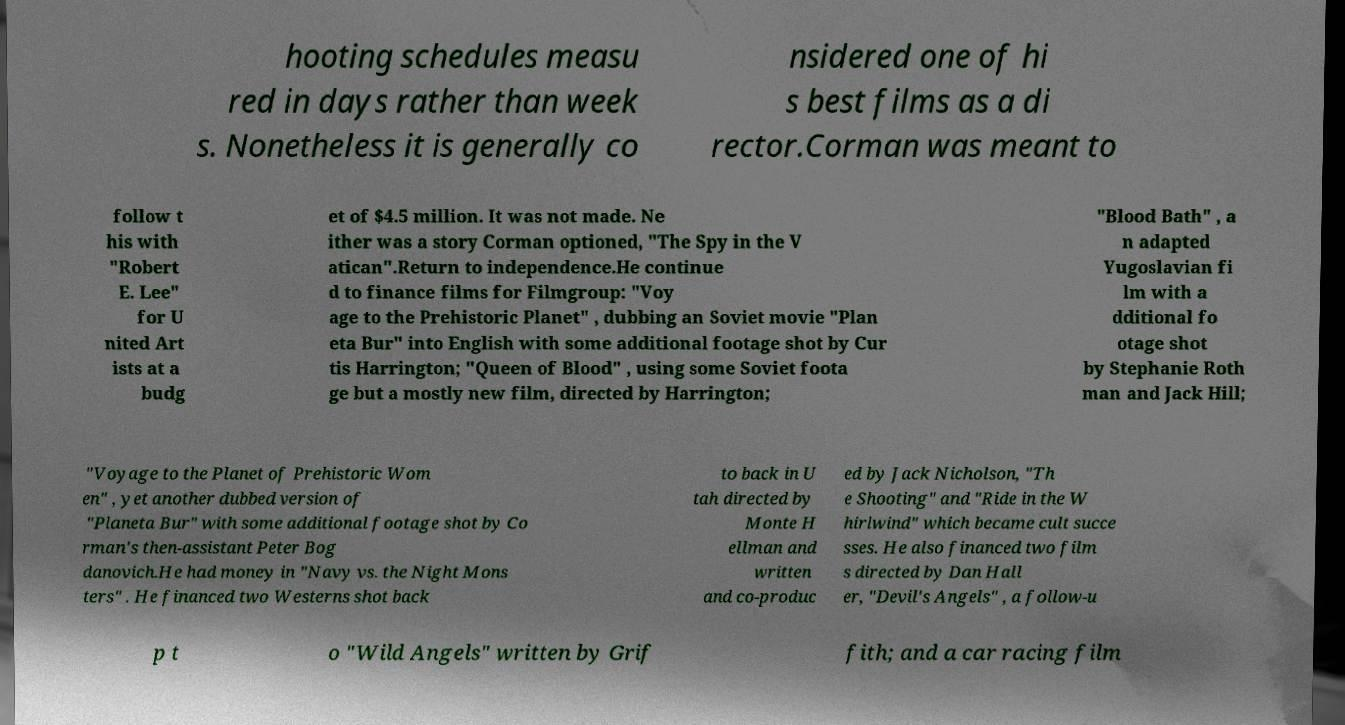Can you accurately transcribe the text from the provided image for me? hooting schedules measu red in days rather than week s. Nonetheless it is generally co nsidered one of hi s best films as a di rector.Corman was meant to follow t his with "Robert E. Lee" for U nited Art ists at a budg et of $4.5 million. It was not made. Ne ither was a story Corman optioned, "The Spy in the V atican".Return to independence.He continue d to finance films for Filmgroup: "Voy age to the Prehistoric Planet" , dubbing an Soviet movie "Plan eta Bur" into English with some additional footage shot by Cur tis Harrington; "Queen of Blood" , using some Soviet foota ge but a mostly new film, directed by Harrington; "Blood Bath" , a n adapted Yugoslavian fi lm with a dditional fo otage shot by Stephanie Roth man and Jack Hill; "Voyage to the Planet of Prehistoric Wom en" , yet another dubbed version of "Planeta Bur" with some additional footage shot by Co rman's then-assistant Peter Bog danovich.He had money in "Navy vs. the Night Mons ters" . He financed two Westerns shot back to back in U tah directed by Monte H ellman and written and co-produc ed by Jack Nicholson, "Th e Shooting" and "Ride in the W hirlwind" which became cult succe sses. He also financed two film s directed by Dan Hall er, "Devil's Angels" , a follow-u p t o "Wild Angels" written by Grif fith; and a car racing film 